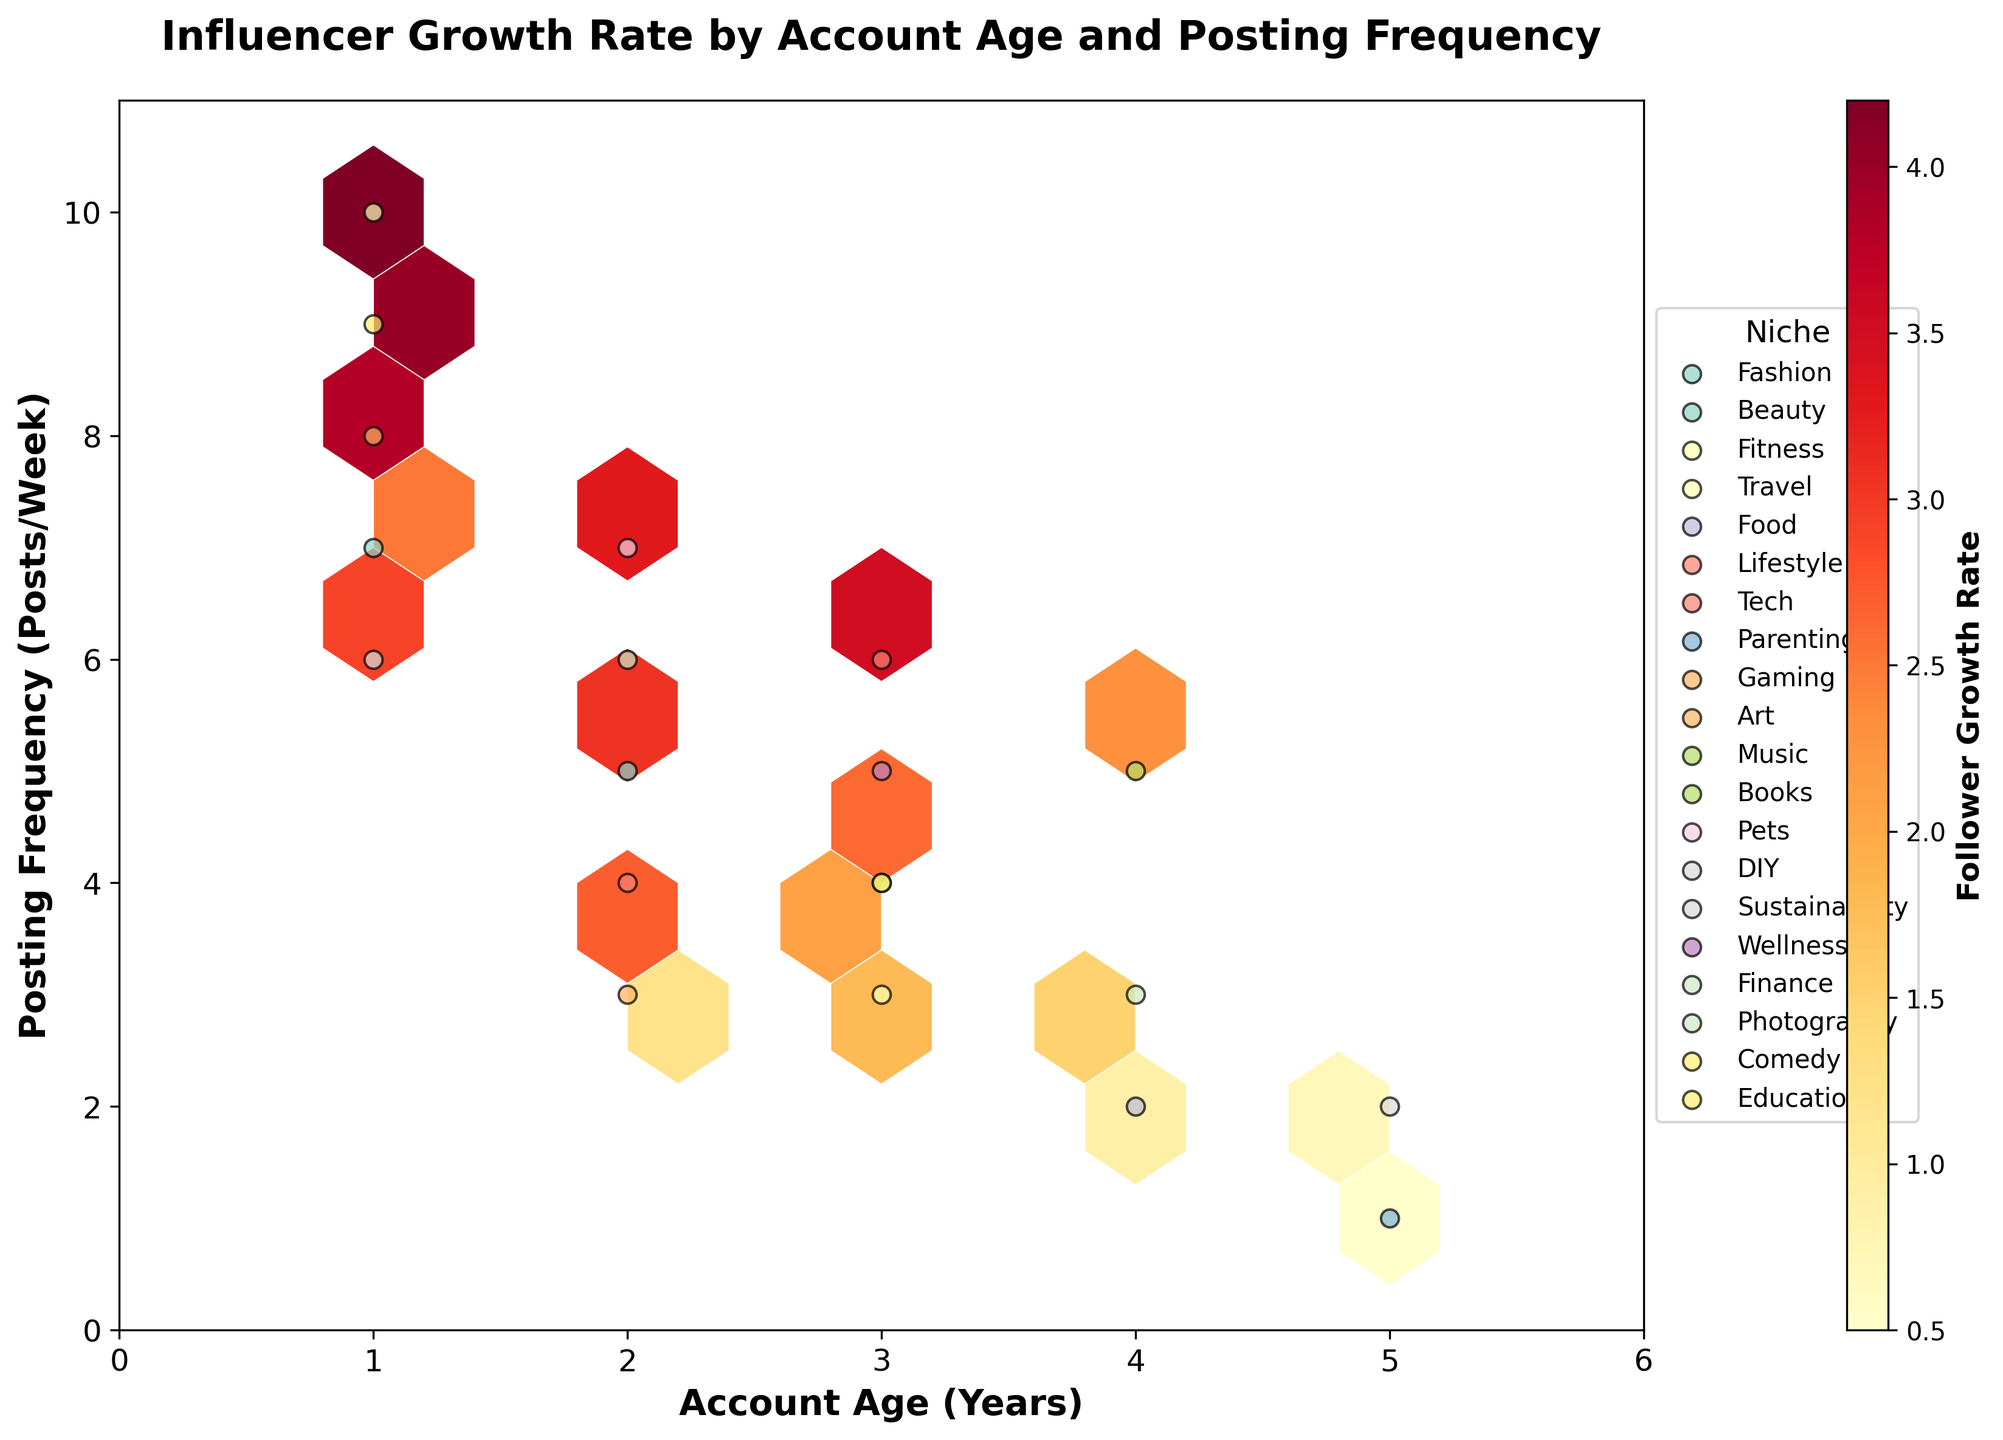What's the title of the figure? The title is usually located at the top of the plot. In this case, the title specifically mentions the content of the figure. It reads, 'Influencer Growth Rate by Account Age and Posting Frequency'.
Answer: Influencer Growth Rate by Account Age and Posting Frequency What do the x and y axes represent? The x-axis represents 'Account Age (Years)', and the y-axis represents 'Posting Frequency (Posts/Week)'. This can be inferred from the axis labels.
Answer: Account Age (Years) and Posting Frequency (Posts/Week) Which niche has data points represented with the highest follower growth rate? The colorbar labeled 'Follower Growth Rate' indicates the highest values. By identifying the hexagons with the darkest colors and cross-referencing the scatter points, Travel, Comedy, and Gaming niches are associated with these.
Answer: Travel, Comedy, and Gaming What's the follower growth rate range indicated by the color bar? The color bar gradient spans a specific range of values. The text alongside the color bar is labeled 'Follower Growth Rate' and ranges from low (lighter color) to high (darker color). The actual values are not mentioned but can be inferred from context. It ranges around ~0.5 to ~4.2.
Answer: 0.5 to 4.2 What combination of account age and posting frequency results in the highest density of points? Hexbin plots show data density through hexagon fills. The densest area has the highest count of overlapping points, typically appearing where both x and y values are moderate. This is roughly between 2-3 years account age and 4-7 posts/week frequency regions.
Answer: 2-3 years account age and 4-7 posts/week Which niche has the lowest follower growth rate, and what are the corresponding account age and posting frequency for that niche? By looking for the lightest hexagons and cross-referencing the scatter plot, Parenting stands out. Its corresponding values are found around an account age of 5 years and posting frequency of 1 post/week.
Answer: Parenting, 5 years, 1 post/week Are there more niches with higher growth rates at lower account ages or higher account ages? Consider the distribution of darker hexagons and their associated scatter points. More niches with higher growth rates appear at lower account ages (~1-2 years) rather than higher.
Answer: Lower account ages What niche has the broadest range of posting frequencies? By observing scatter point spreads across the y-axis for each color-coded niche, Gaming covers the broadest range, hitting both 6 and 9-10 posts per week.
Answer: Gaming Which niche has the most consistent posting frequency and what is that frequency? The niche with scatter points closely aggregated vertically indicates consistency. Art, mainly concentrated around the 3 posts/week mark shows this.
Answer: Art, 3 posts/week For niches concentrated around the center of the plot, what are their typical follower growth rates? Hexbin in the central region (account age 3 years, 5-6 posts/week) shows consolidated values. By referencing colors, central niches like Tech, Music, and Wellness typically range around a follower growth rate of 2.0-3.5.
Answer: 2.0-3.5 